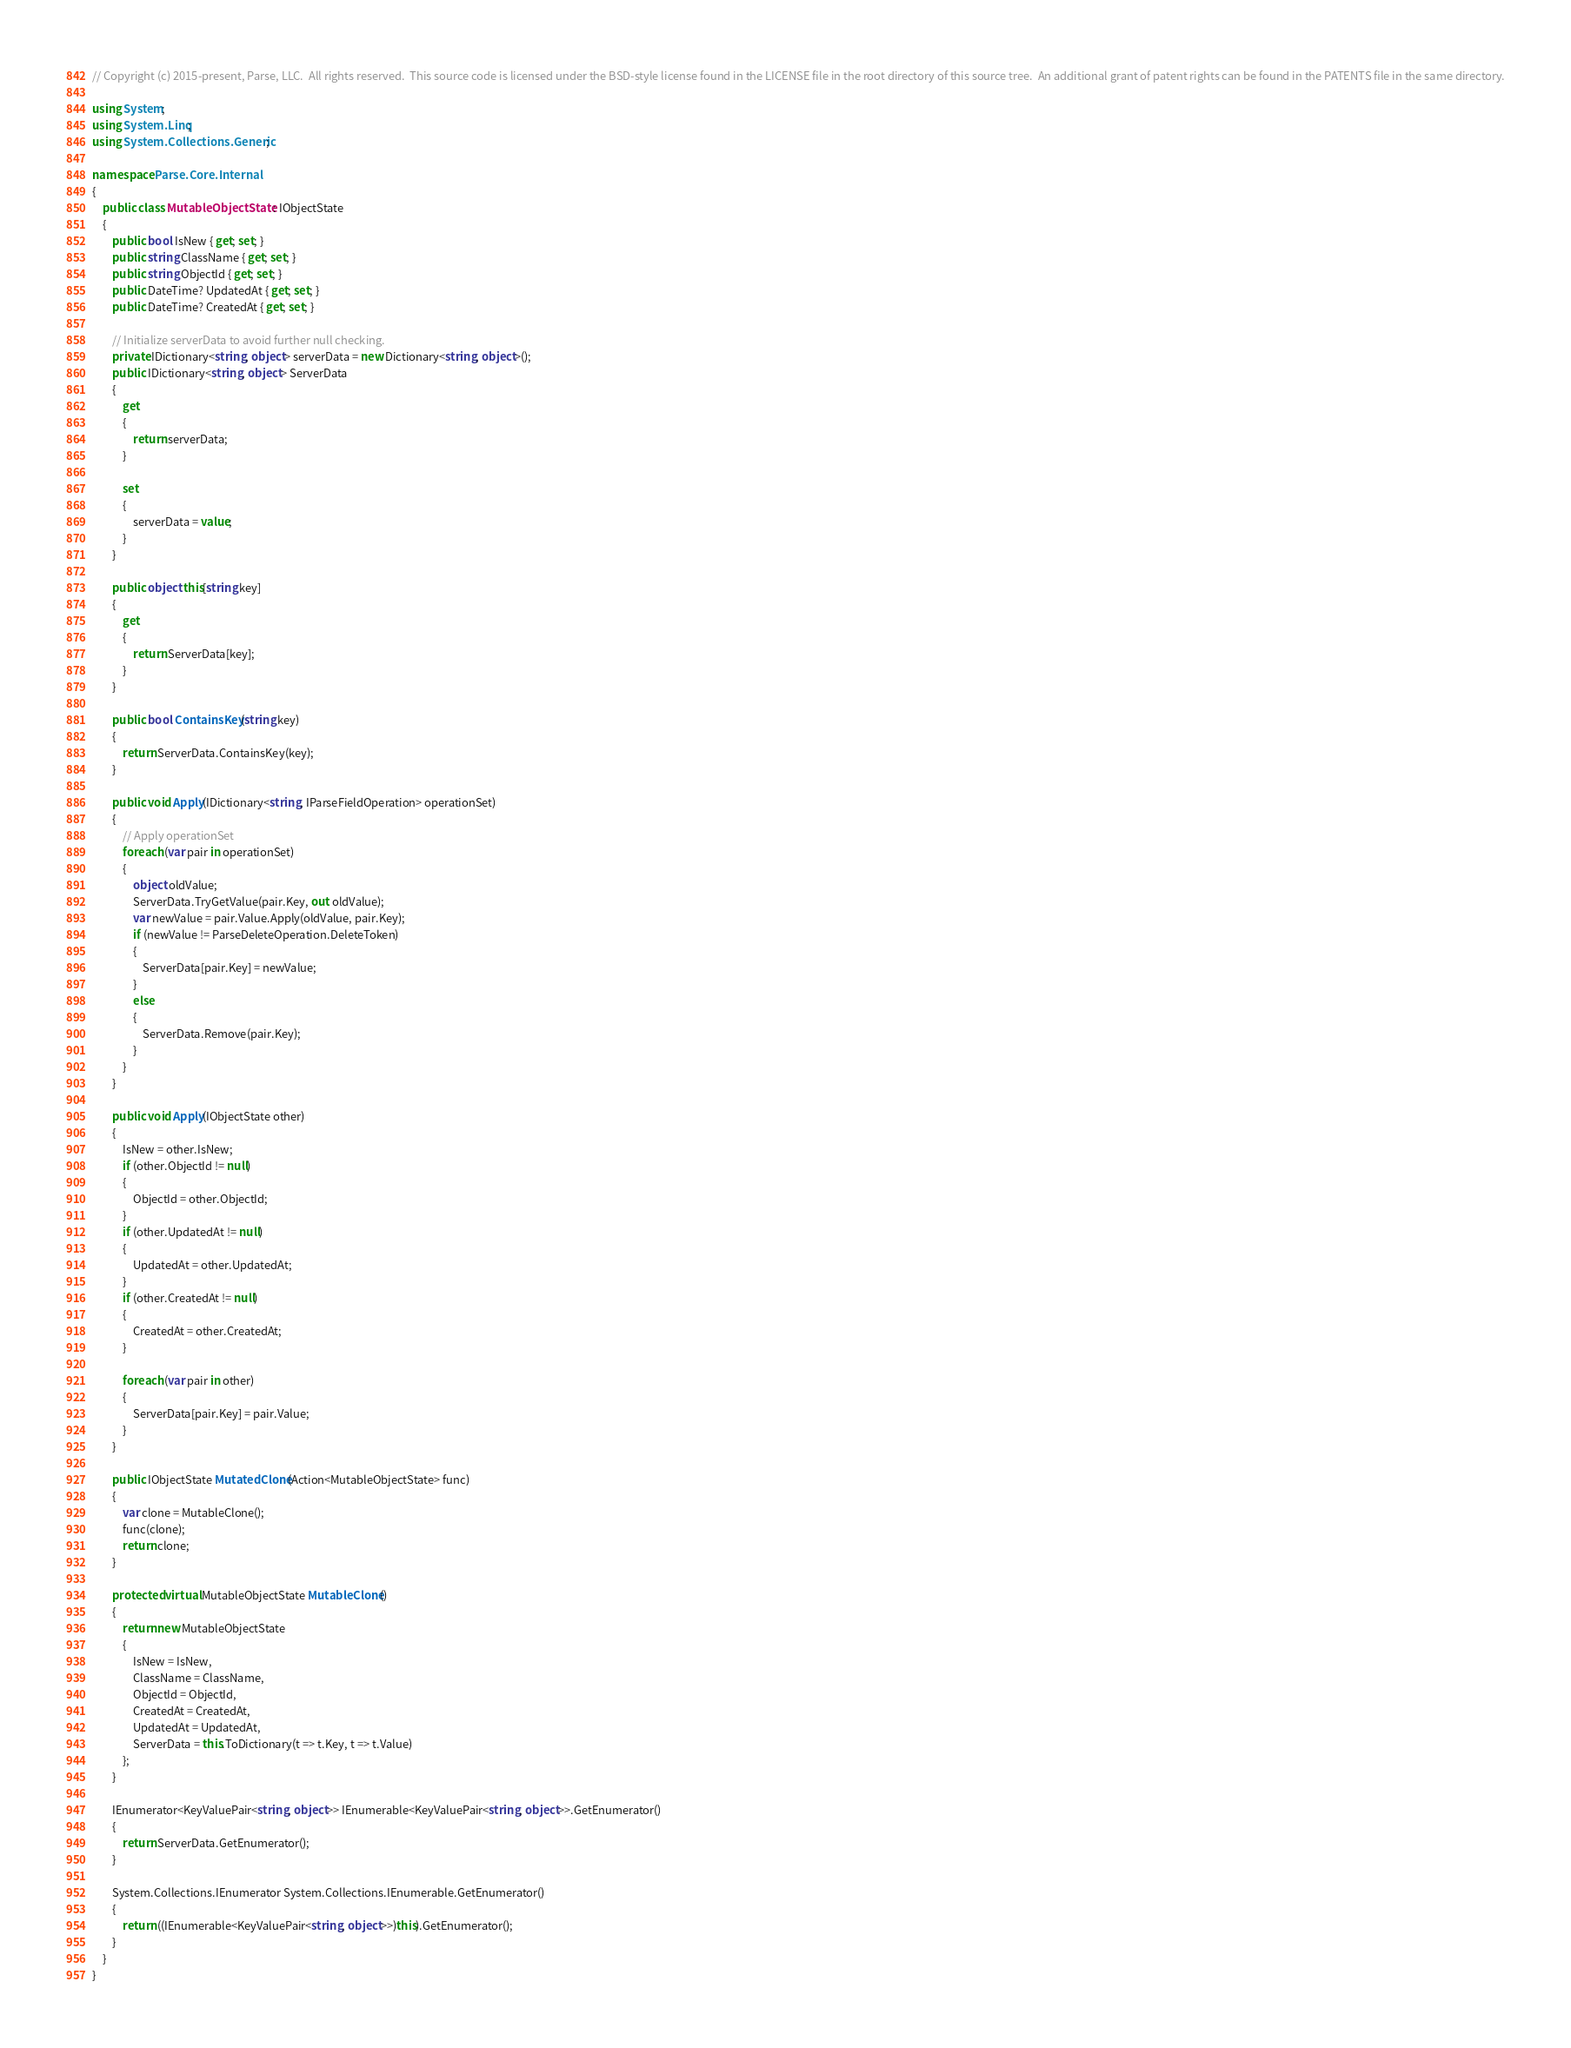Convert code to text. <code><loc_0><loc_0><loc_500><loc_500><_C#_>// Copyright (c) 2015-present, Parse, LLC.  All rights reserved.  This source code is licensed under the BSD-style license found in the LICENSE file in the root directory of this source tree.  An additional grant of patent rights can be found in the PATENTS file in the same directory.

using System;
using System.Linq;
using System.Collections.Generic;

namespace Parse.Core.Internal
{
    public class MutableObjectState : IObjectState
    {
        public bool IsNew { get; set; }
        public string ClassName { get; set; }
        public string ObjectId { get; set; }
        public DateTime? UpdatedAt { get; set; }
        public DateTime? CreatedAt { get; set; }

        // Initialize serverData to avoid further null checking.
        private IDictionary<string, object> serverData = new Dictionary<string, object>();
        public IDictionary<string, object> ServerData
        {
            get
            {
                return serverData;
            }

            set
            {
                serverData = value;
            }
        }

        public object this[string key]
        {
            get
            {
                return ServerData[key];
            }
        }

        public bool ContainsKey(string key)
        {
            return ServerData.ContainsKey(key);
        }

        public void Apply(IDictionary<string, IParseFieldOperation> operationSet)
        {
            // Apply operationSet
            foreach (var pair in operationSet)
            {
                object oldValue;
                ServerData.TryGetValue(pair.Key, out oldValue);
                var newValue = pair.Value.Apply(oldValue, pair.Key);
                if (newValue != ParseDeleteOperation.DeleteToken)
                {
                    ServerData[pair.Key] = newValue;
                }
                else
                {
                    ServerData.Remove(pair.Key);
                }
            }
        }

        public void Apply(IObjectState other)
        {
            IsNew = other.IsNew;
            if (other.ObjectId != null)
            {
                ObjectId = other.ObjectId;
            }
            if (other.UpdatedAt != null)
            {
                UpdatedAt = other.UpdatedAt;
            }
            if (other.CreatedAt != null)
            {
                CreatedAt = other.CreatedAt;
            }

            foreach (var pair in other)
            {
                ServerData[pair.Key] = pair.Value;
            }
        }

        public IObjectState MutatedClone(Action<MutableObjectState> func)
        {
            var clone = MutableClone();
            func(clone);
            return clone;
        }

        protected virtual MutableObjectState MutableClone()
        {
            return new MutableObjectState
            {
                IsNew = IsNew,
                ClassName = ClassName,
                ObjectId = ObjectId,
                CreatedAt = CreatedAt,
                UpdatedAt = UpdatedAt,
                ServerData = this.ToDictionary(t => t.Key, t => t.Value)
            };
        }

        IEnumerator<KeyValuePair<string, object>> IEnumerable<KeyValuePair<string, object>>.GetEnumerator()
        {
            return ServerData.GetEnumerator();
        }

        System.Collections.IEnumerator System.Collections.IEnumerable.GetEnumerator()
        {
            return ((IEnumerable<KeyValuePair<string, object>>)this).GetEnumerator();
        }
    }
}
</code> 